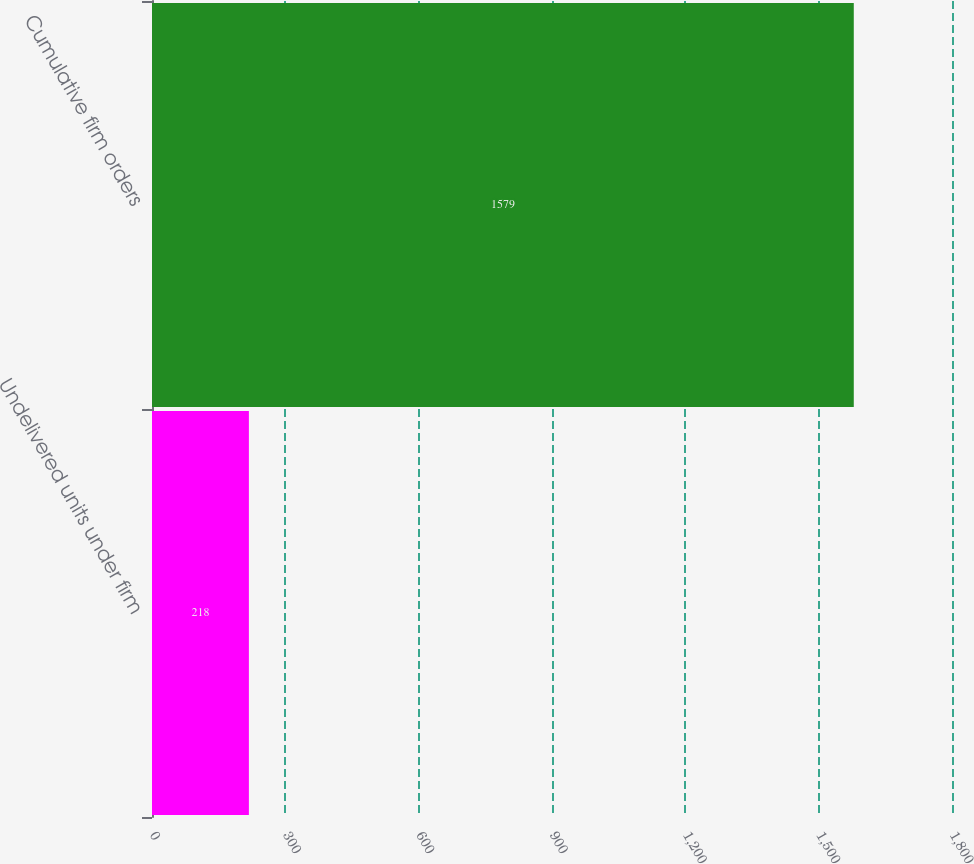Convert chart to OTSL. <chart><loc_0><loc_0><loc_500><loc_500><bar_chart><fcel>Undelivered units under firm<fcel>Cumulative firm orders<nl><fcel>218<fcel>1579<nl></chart> 